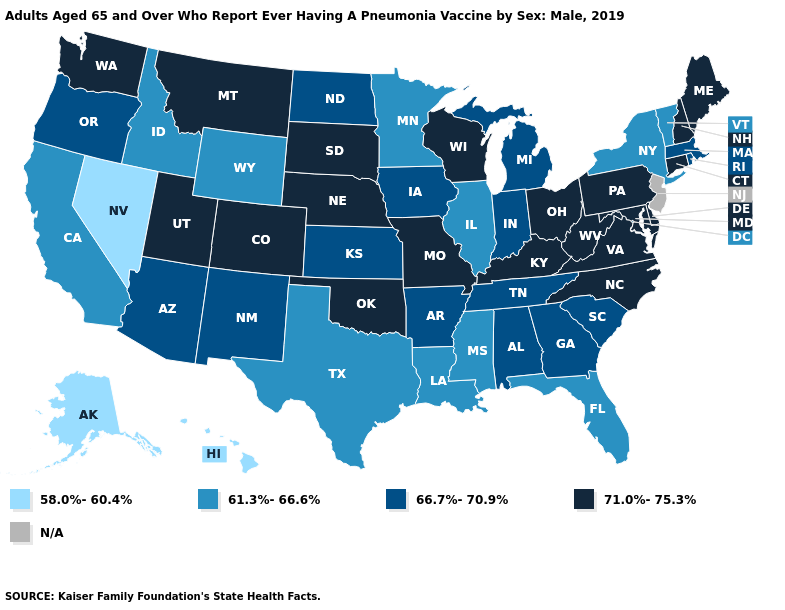Among the states that border Washington , which have the highest value?
Be succinct. Oregon. Name the states that have a value in the range 66.7%-70.9%?
Short answer required. Alabama, Arizona, Arkansas, Georgia, Indiana, Iowa, Kansas, Massachusetts, Michigan, New Mexico, North Dakota, Oregon, Rhode Island, South Carolina, Tennessee. What is the value of Colorado?
Concise answer only. 71.0%-75.3%. Among the states that border New York , does Pennsylvania have the highest value?
Answer briefly. Yes. What is the lowest value in the West?
Keep it brief. 58.0%-60.4%. Among the states that border New Jersey , does Pennsylvania have the lowest value?
Write a very short answer. No. What is the highest value in states that border South Carolina?
Be succinct. 71.0%-75.3%. Name the states that have a value in the range N/A?
Keep it brief. New Jersey. What is the value of South Dakota?
Be succinct. 71.0%-75.3%. What is the value of Connecticut?
Concise answer only. 71.0%-75.3%. Among the states that border New Hampshire , which have the highest value?
Short answer required. Maine. What is the value of North Dakota?
Give a very brief answer. 66.7%-70.9%. Among the states that border Kentucky , which have the lowest value?
Quick response, please. Illinois. What is the highest value in states that border Nebraska?
Write a very short answer. 71.0%-75.3%. 